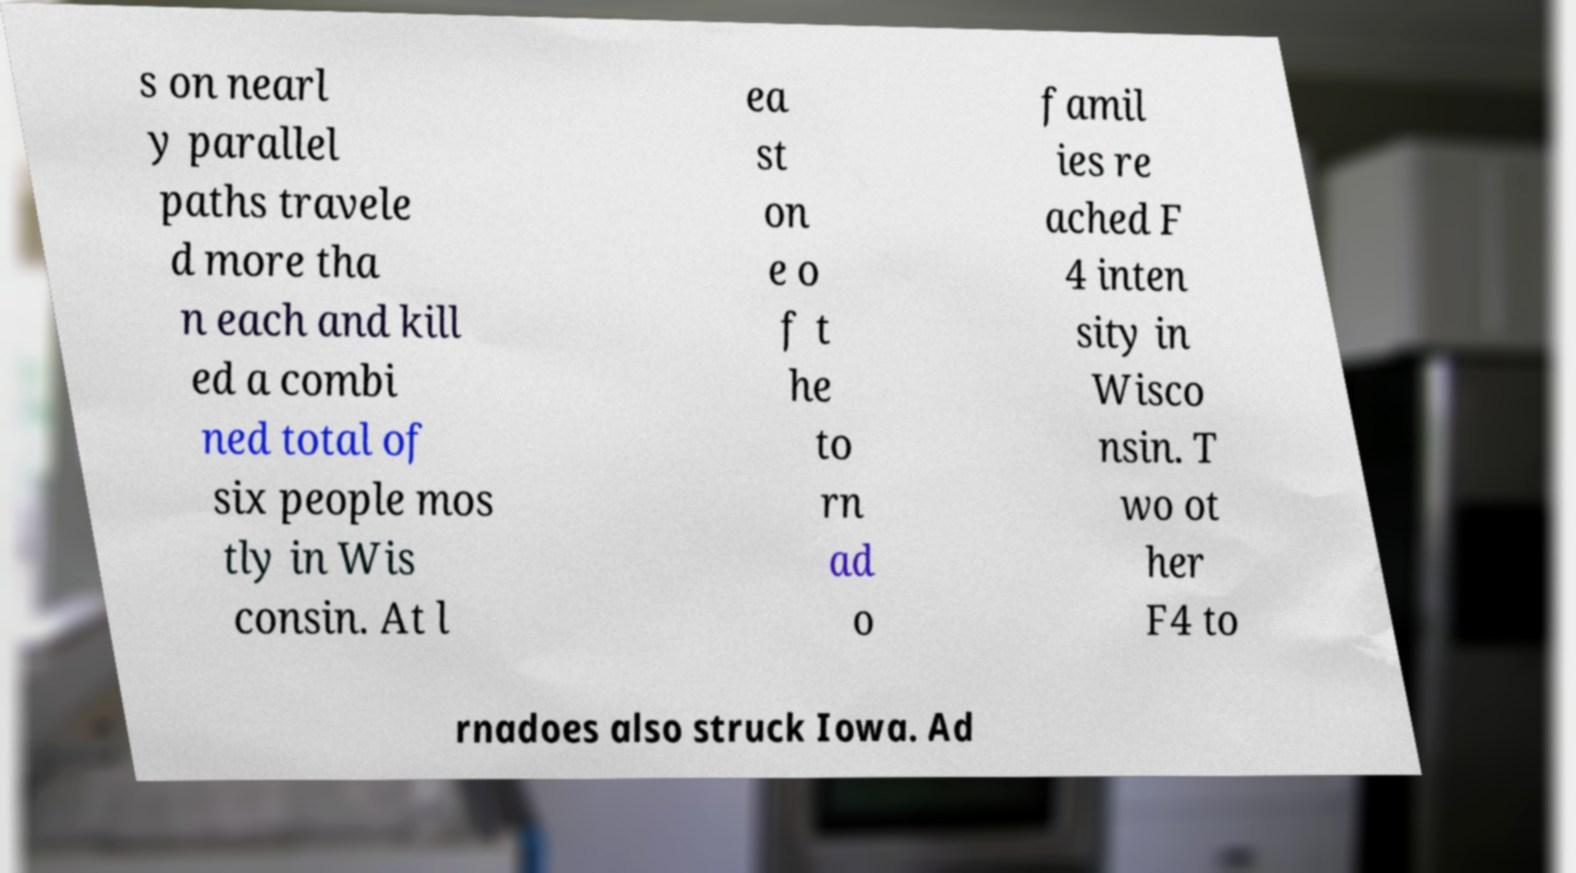Can you read and provide the text displayed in the image?This photo seems to have some interesting text. Can you extract and type it out for me? s on nearl y parallel paths travele d more tha n each and kill ed a combi ned total of six people mos tly in Wis consin. At l ea st on e o f t he to rn ad o famil ies re ached F 4 inten sity in Wisco nsin. T wo ot her F4 to rnadoes also struck Iowa. Ad 